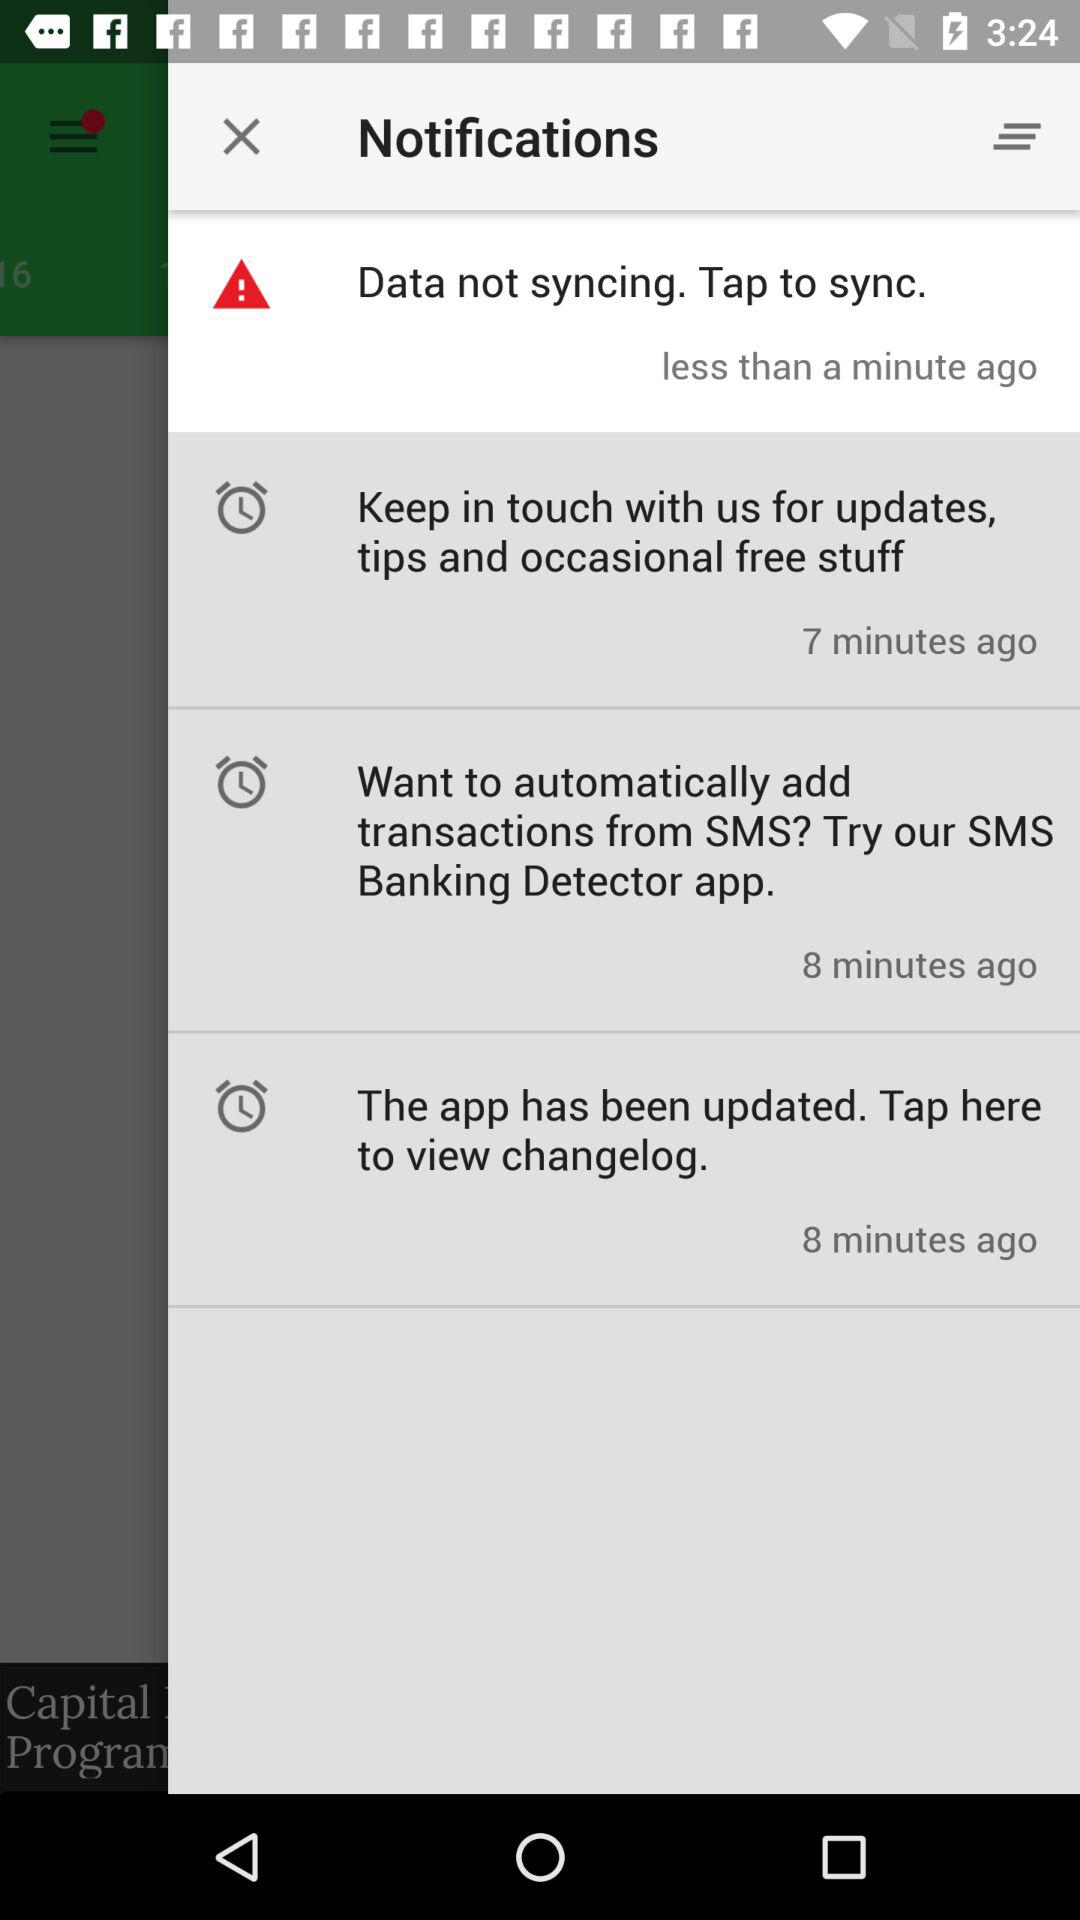What is the notification that arrived less than a minute ago? The notification that arrived less than a minute ago is "Data not syncing. Tap to sync". 